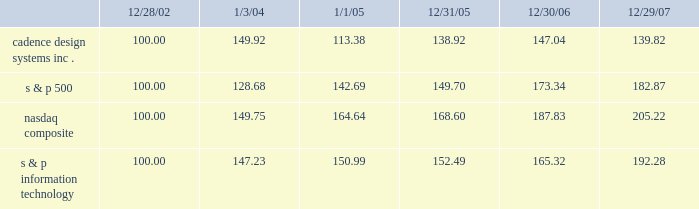The graph below matches cadence design systems , inc . 2019s cumulative 5-year total shareholder return on common stock with the cumulative total returns of the s&p 500 index , the s&p information technology index , and the nasdaq composite index .
The graph assumes that the value of the investment in our common stock , and in each index ( including reinvestment of dividends ) was $ 100 on december 28 , 2002 and tracks it through december 29 , 2007 .
Comparison of 5 year cumulative total return* among cadence design systems , inc. , the s&p 500 index , the nasdaq composite index and the s&p information technology index 12/29/0712/30/0612/31/051/1/051/3/0412/28/02 cadence design systems , inc .
Nasdaq composite s & p information technology s & p 500 * $ 100 invested on 12/28/02 in stock or on 12/31/02 in index-including reinvestment of dividends .
Indexes calculated on month-end basis .
Copyright b7 2007 , standard & poor 2019s , a division of the mcgraw-hill companies , inc .
All rights reserved .
Www.researchdatagroup.com/s&p.htm .
The stock price performance included in this graph is not necessarily indicative of future stock price performance .
What is the roi of an investment in cadence design system from 2006 to 2007? 
Computations: ((139.82 - 147.04) / 147.04)
Answer: -0.0491. 